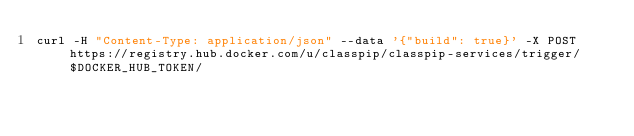Convert code to text. <code><loc_0><loc_0><loc_500><loc_500><_Bash_>curl -H "Content-Type: application/json" --data '{"build": true}' -X POST https://registry.hub.docker.com/u/classpip/classpip-services/trigger/$DOCKER_HUB_TOKEN/
</code> 